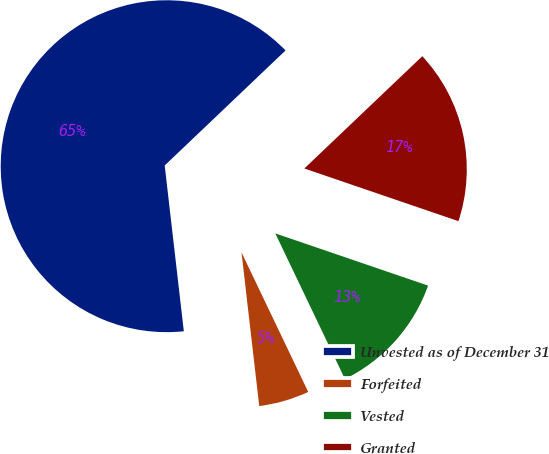<chart> <loc_0><loc_0><loc_500><loc_500><pie_chart><fcel>Unvested as of December 31<fcel>Forfeited<fcel>Vested<fcel>Granted<nl><fcel>64.72%<fcel>5.27%<fcel>12.66%<fcel>17.35%<nl></chart> 